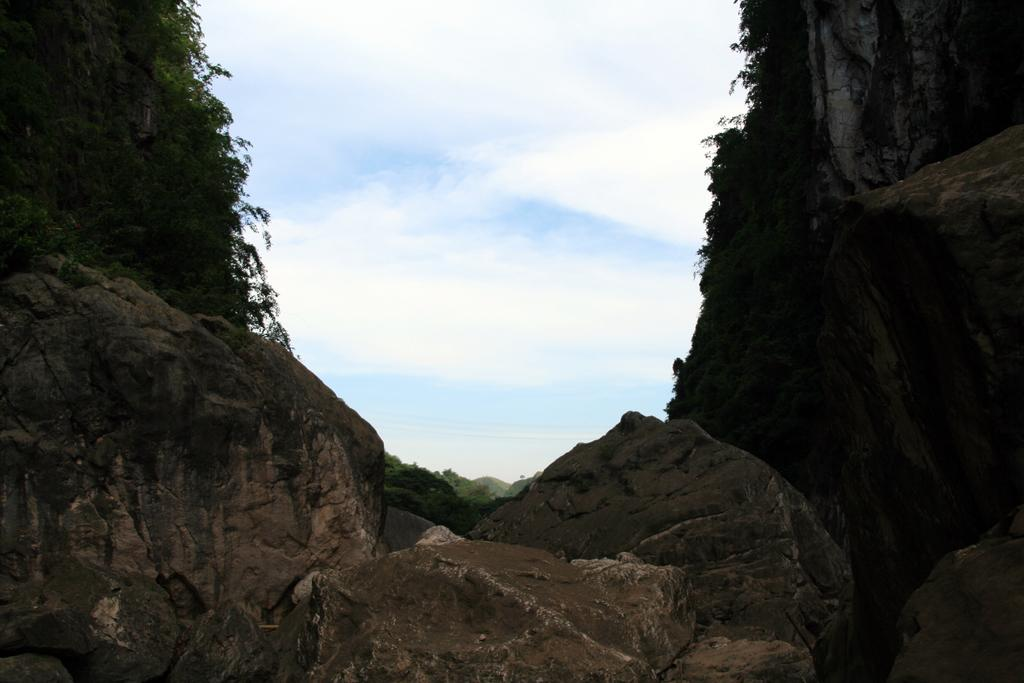What type of natural elements can be seen in the image? There are rocks in the image. How are the rocks arranged in the image? The rocks are positioned from left to right. What else can be seen on the rocks? There are plants visible on the rocks. What is the condition of the sky in the image? The sky is cloudy in the image. Can you tell me about the historical agreement that took place on the rocks in the image? There is no mention of any historical agreement in the image; it simply features rocks with plants and a cloudy sky. How many trees are visible on the rocks in the image? There are no trees visible on the rocks in the image; only plants are present. 